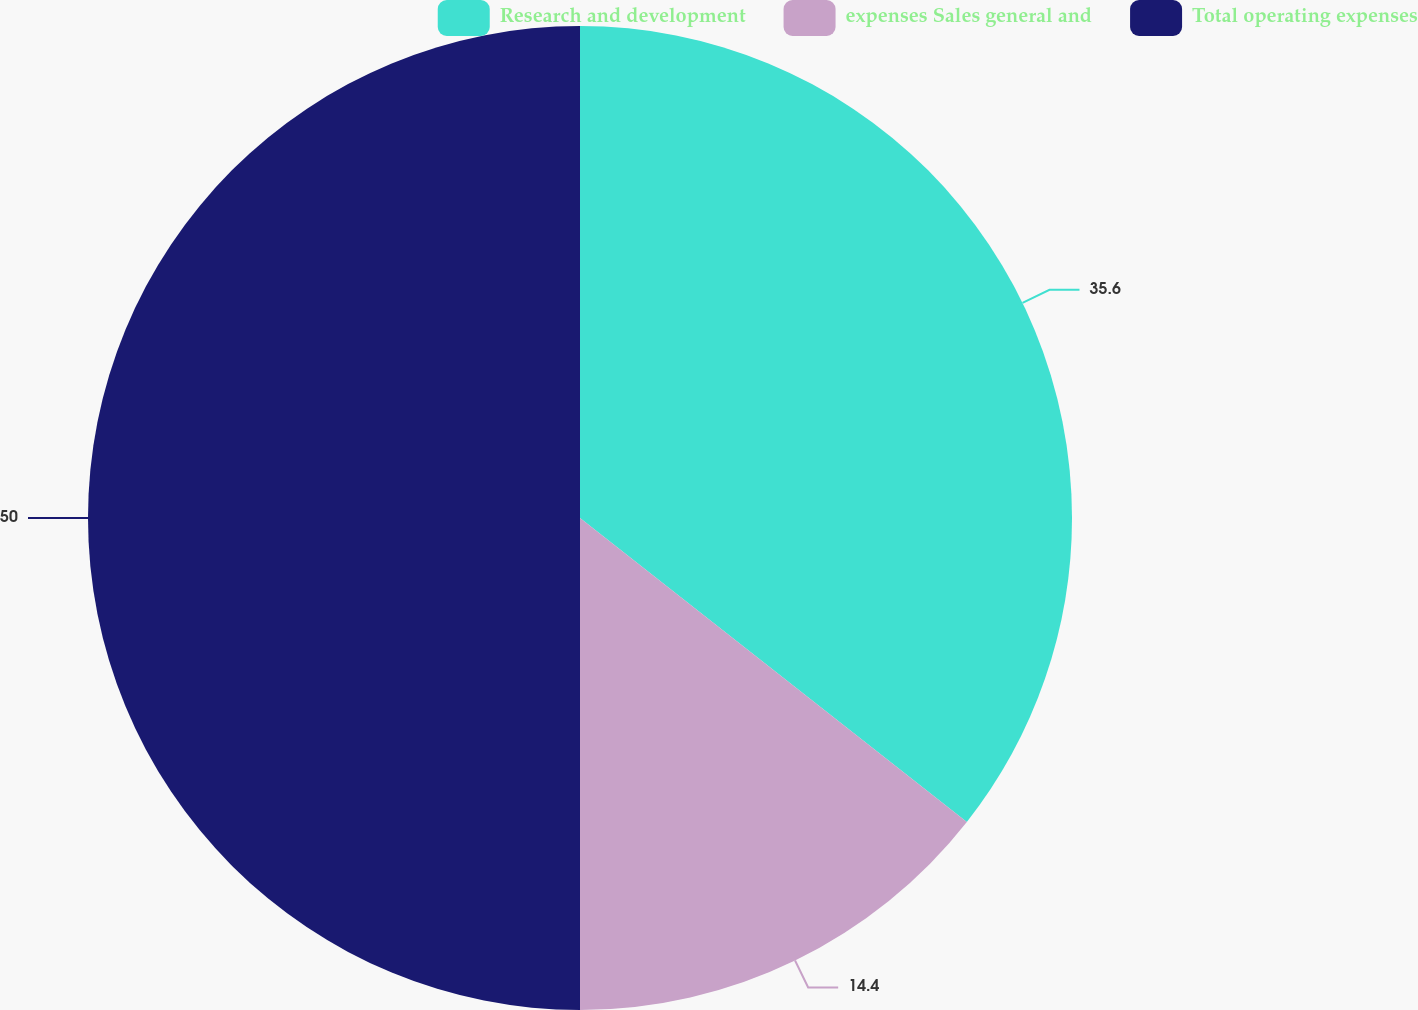Convert chart. <chart><loc_0><loc_0><loc_500><loc_500><pie_chart><fcel>Research and development<fcel>expenses Sales general and<fcel>Total operating expenses<nl><fcel>35.6%<fcel>14.4%<fcel>50.0%<nl></chart> 